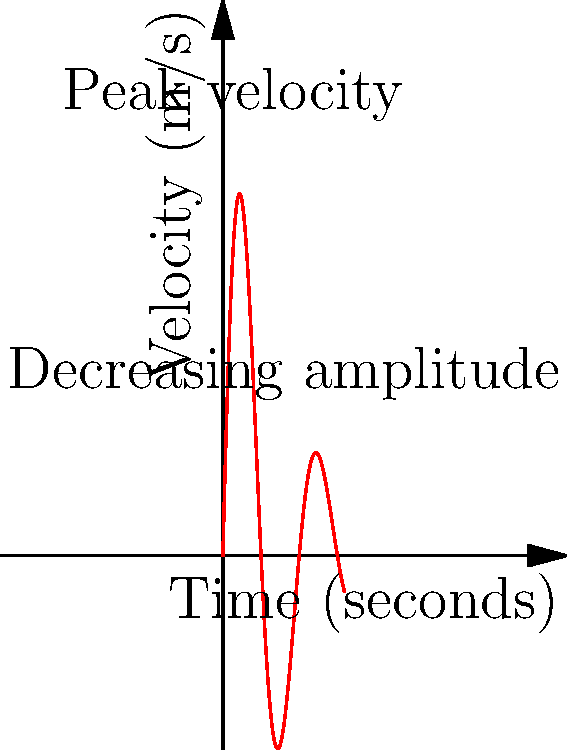In a youth baseball training session, you're analyzing the velocity of a baseball after it's hit. The graph shows the velocity of the ball over time. What physical factors contribute to the decreasing amplitude of the curve, and how does this relate to the ball's eventual return to the ground? To understand the decreasing amplitude of the curve and its relation to the ball's return to the ground, let's analyze the graph step-by-step:

1. Initial velocity: The ball starts with a high velocity immediately after being hit, represented by the first peak on the graph.

2. Oscillating pattern: The curve shows an oscillating pattern, indicating that the ball's velocity changes direction periodically. This is due to the ball's spin and air resistance.

3. Decreasing amplitude: The amplitude of the oscillations decreases over time. This is caused by several physical factors:
   a) Air resistance: As the ball moves through the air, it encounters friction, which gradually reduces its overall velocity.
   b) Gravity: The constant downward force of gravity affects the ball's vertical velocity component.
   c) Spin decay: The initial spin imparted on the ball gradually decreases due to air resistance, reducing the Magnus effect.

4. Energy dissipation: The decreasing amplitude represents a loss of kinetic energy as the ball's motion is opposed by air resistance and gravity.

5. Approach to zero: As the amplitude decreases, the velocity approaches zero, indicating that the ball is losing speed and height.

6. Return to ground: The point where the curve finally reaches zero velocity (or close to it) represents the moment when the ball returns to the ground or is caught.

This analysis shows how air resistance, gravity, and spin decay work together to reduce the ball's velocity and ultimately bring it back to earth, which is crucial for players to understand when predicting ball trajectories and planning defensive strategies.
Answer: Air resistance, gravity, and spin decay cause decreasing amplitude, leading to velocity reduction and the ball's return to ground. 